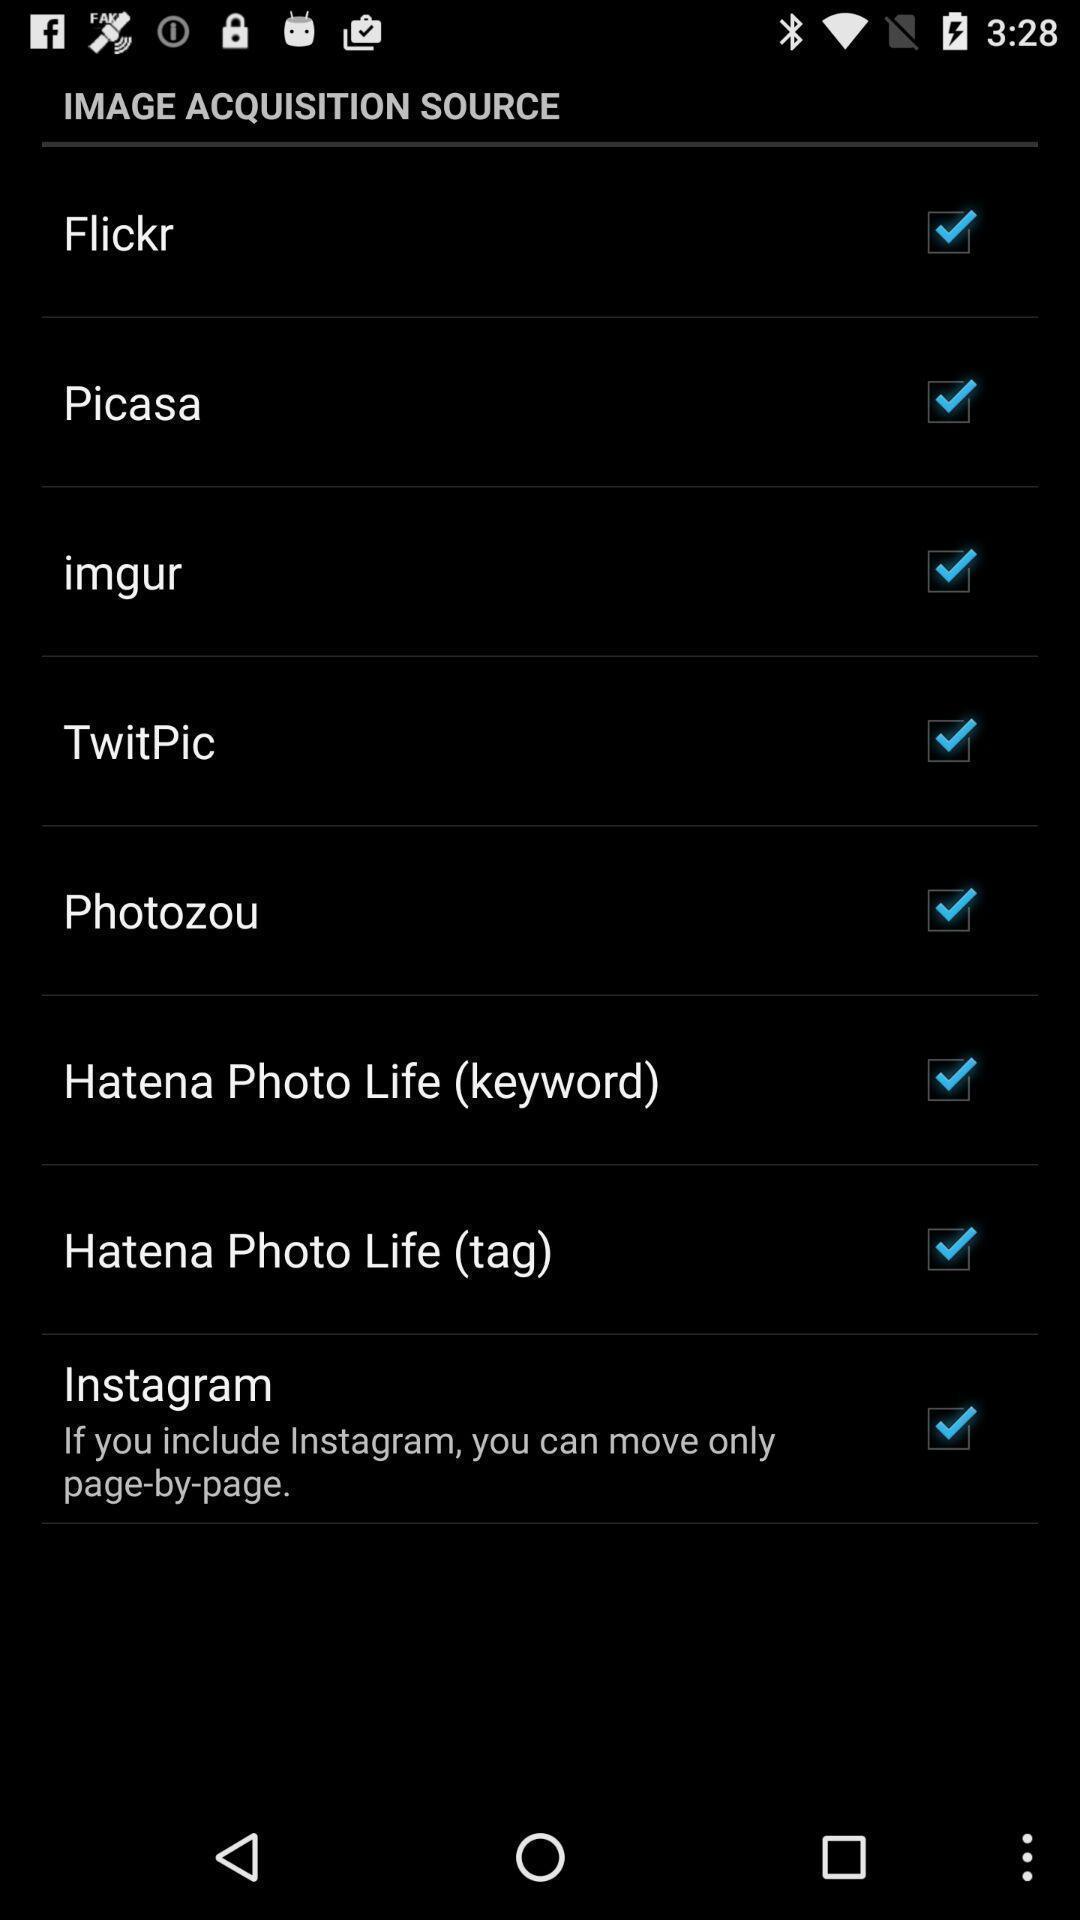Describe this image in words. Settings page. 